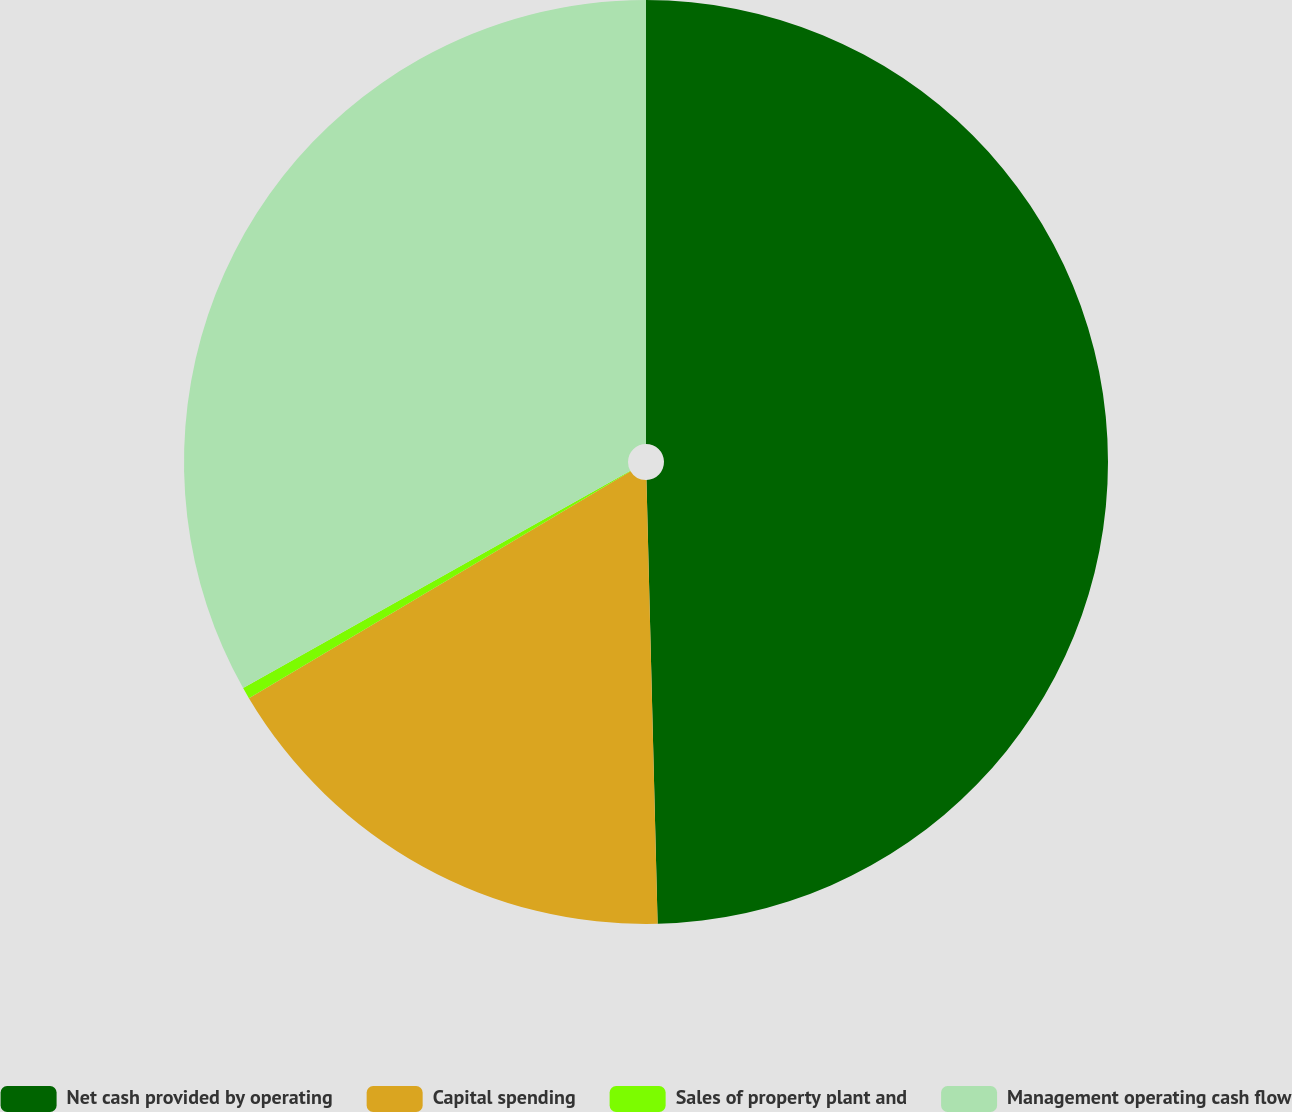<chart> <loc_0><loc_0><loc_500><loc_500><pie_chart><fcel>Net cash provided by operating<fcel>Capital spending<fcel>Sales of property plant and<fcel>Management operating cash flow<nl><fcel>49.6%<fcel>16.86%<fcel>0.4%<fcel>33.14%<nl></chart> 